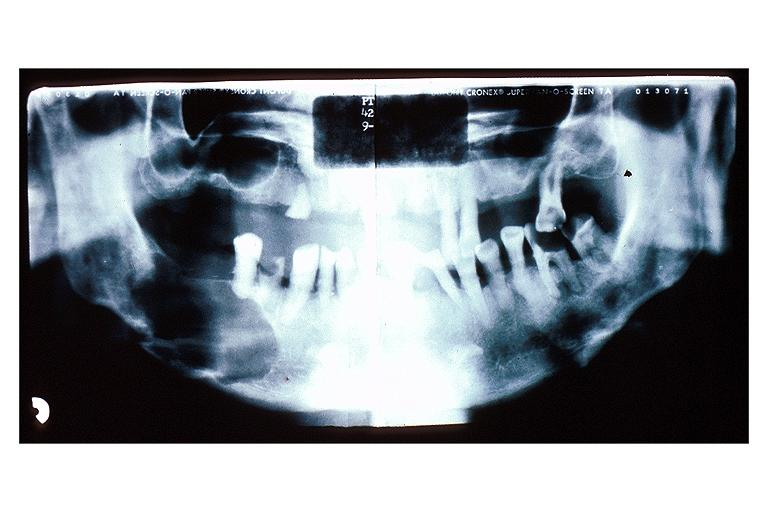s oral present?
Answer the question using a single word or phrase. Yes 